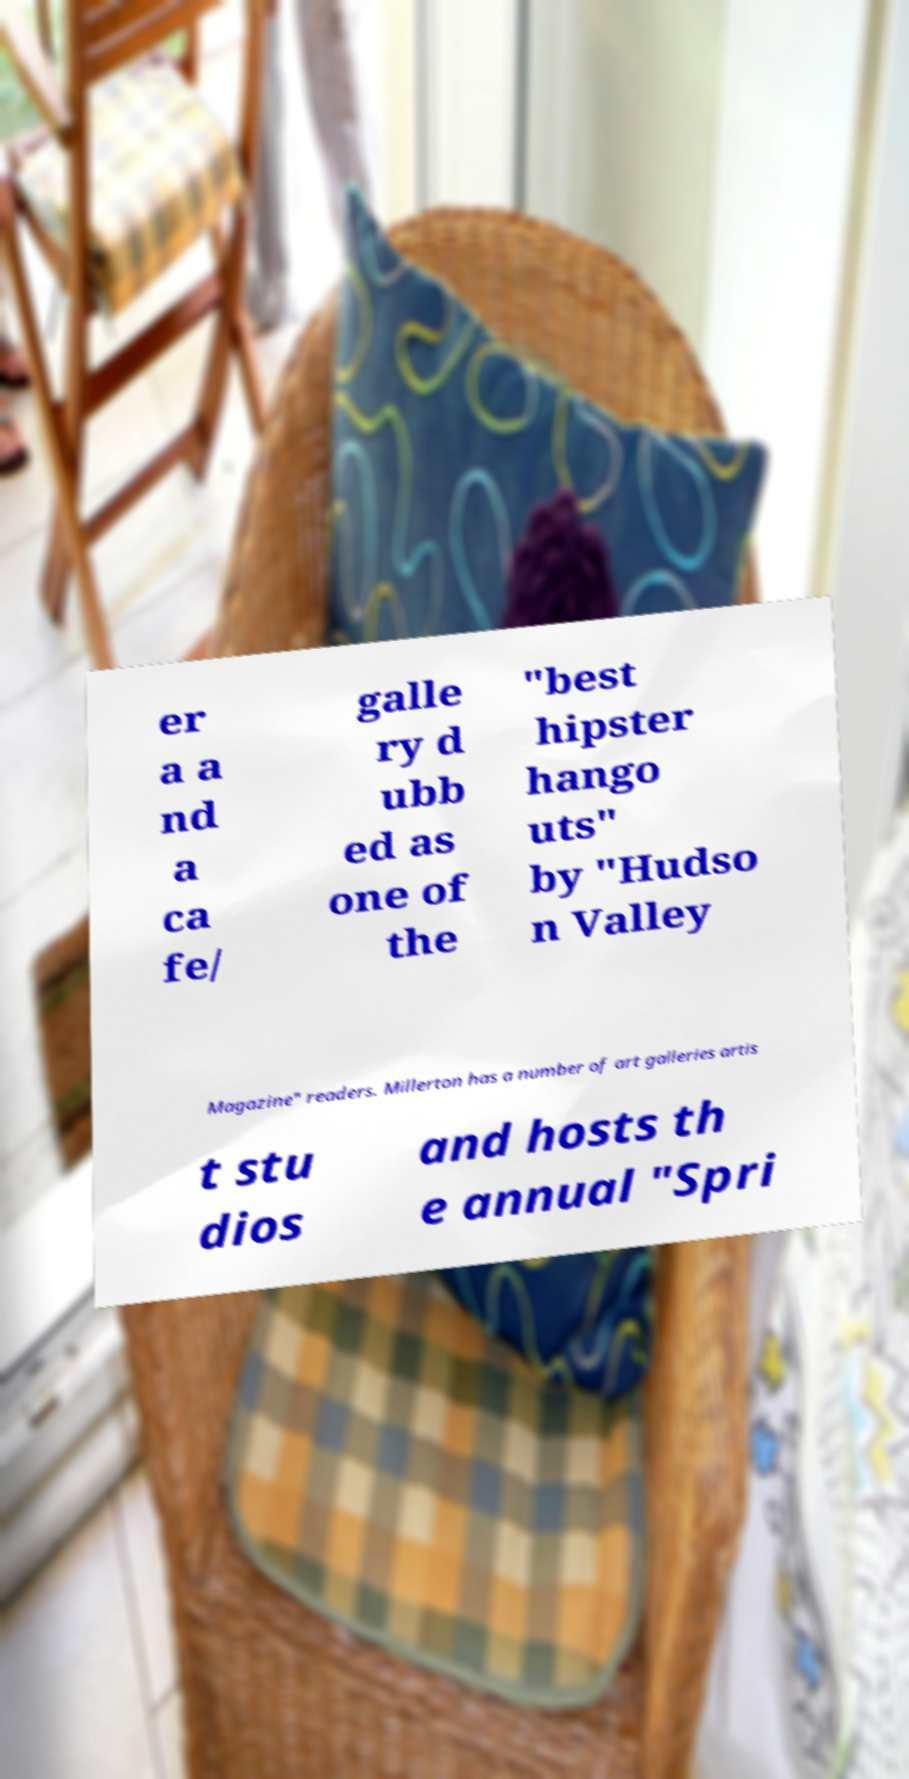For documentation purposes, I need the text within this image transcribed. Could you provide that? er a a nd a ca fe/ galle ry d ubb ed as one of the "best hipster hango uts" by "Hudso n Valley Magazine" readers. Millerton has a number of art galleries artis t stu dios and hosts th e annual "Spri 